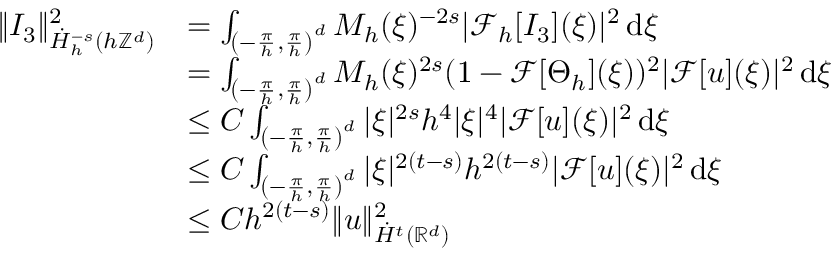<formula> <loc_0><loc_0><loc_500><loc_500>\begin{array} { r l } { \| I _ { 3 } \| _ { \dot { H } _ { h } ^ { - s } ( h \mathbb { Z } ^ { d } ) } ^ { 2 } } & { = \int _ { \left ( - \frac { \pi } { h } , \frac { \pi } { h } \right ) ^ { d } } M _ { h } ( \xi ) ^ { - 2 s } | \mathcal { F } _ { h } [ I _ { 3 } ] ( \xi ) | ^ { 2 } \, d \xi } \\ & { = \int _ { \left ( - \frac { \pi } { h } , \frac { \pi } { h } \right ) ^ { d } } M _ { h } ( \xi ) ^ { 2 s } ( 1 - \mathcal { F } [ \Theta _ { h } ] ( \xi ) ) ^ { 2 } | \mathcal { F } [ u ] ( \xi ) | ^ { 2 } \, d \xi } \\ & { \leq C \int _ { \left ( - \frac { \pi } { h } , \frac { \pi } { h } \right ) ^ { d } } | \xi | ^ { 2 s } h ^ { 4 } | \xi | ^ { 4 } | \mathcal { F } [ u ] ( \xi ) | ^ { 2 } \, d \xi } \\ & { \leq C \int _ { \left ( - \frac { \pi } { h } , \frac { \pi } { h } \right ) ^ { d } } | \xi | ^ { 2 ( t - s ) } h ^ { 2 ( t - s ) } | \mathcal { F } [ u ] ( \xi ) | ^ { 2 } \, d \xi } \\ & { \leq C h ^ { 2 ( t - s ) } \| u \| _ { \dot { H } ^ { t } ( \mathbb { R } ^ { d } ) } ^ { 2 } } \end{array}</formula> 